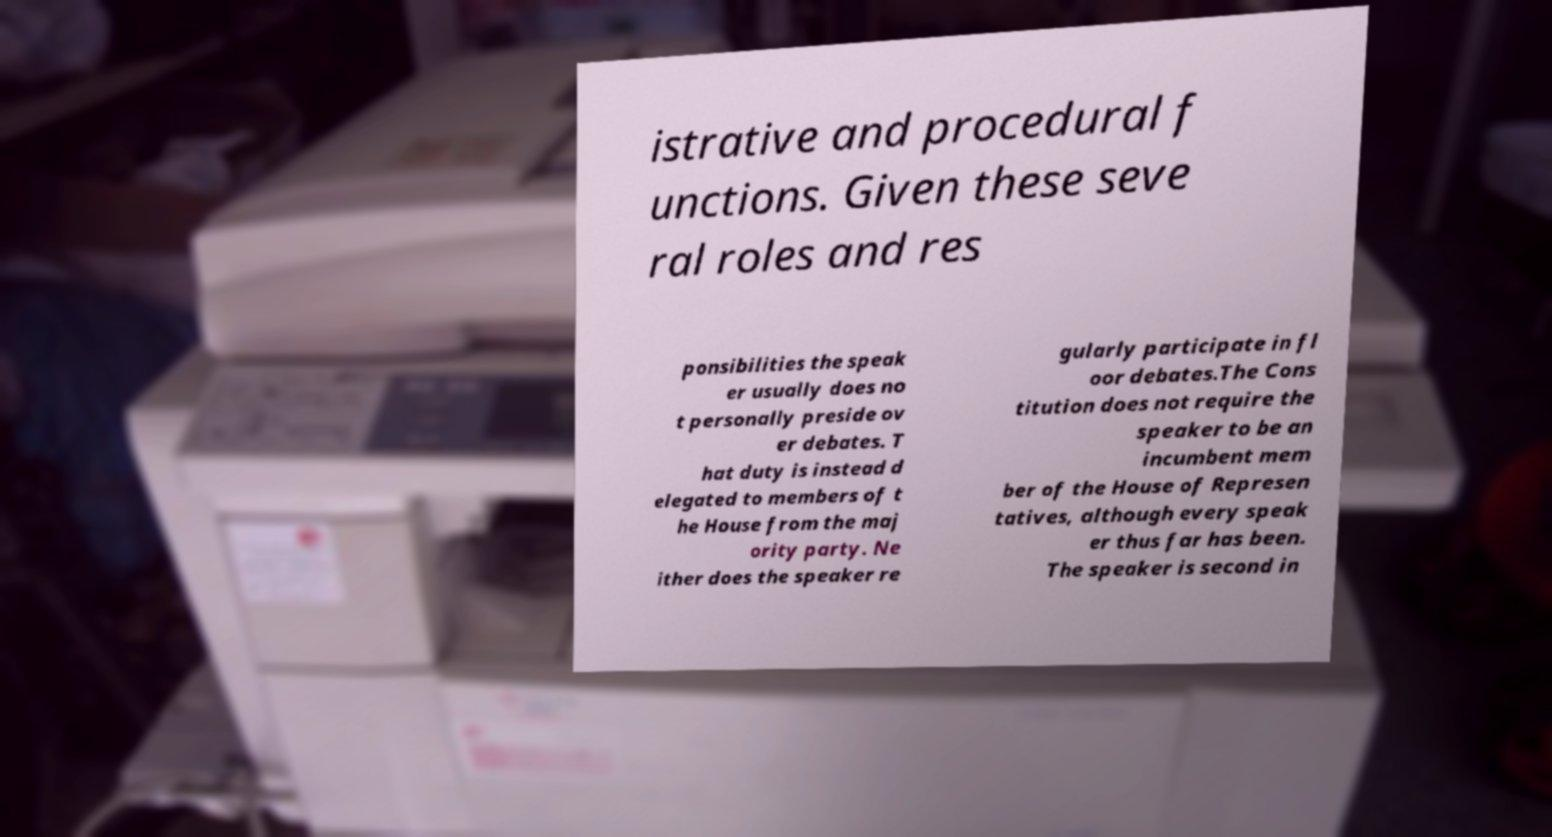Can you read and provide the text displayed in the image?This photo seems to have some interesting text. Can you extract and type it out for me? istrative and procedural f unctions. Given these seve ral roles and res ponsibilities the speak er usually does no t personally preside ov er debates. T hat duty is instead d elegated to members of t he House from the maj ority party. Ne ither does the speaker re gularly participate in fl oor debates.The Cons titution does not require the speaker to be an incumbent mem ber of the House of Represen tatives, although every speak er thus far has been. The speaker is second in 